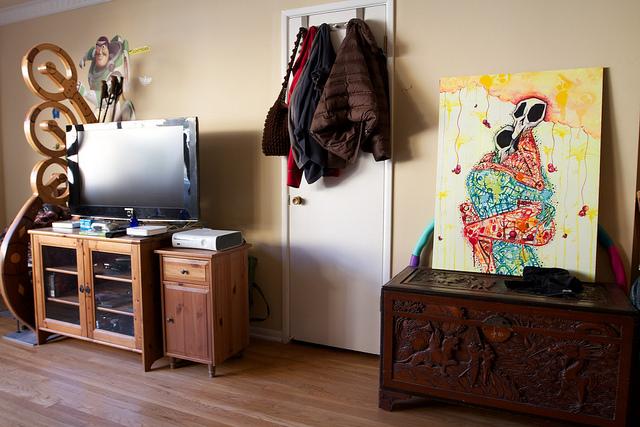What type of floor is in the photo?
Answer briefly. Wood. What is hanging on the door?
Short answer required. Coats. What is in the painting on top of the chest?
Short answer required. Skeletons. 